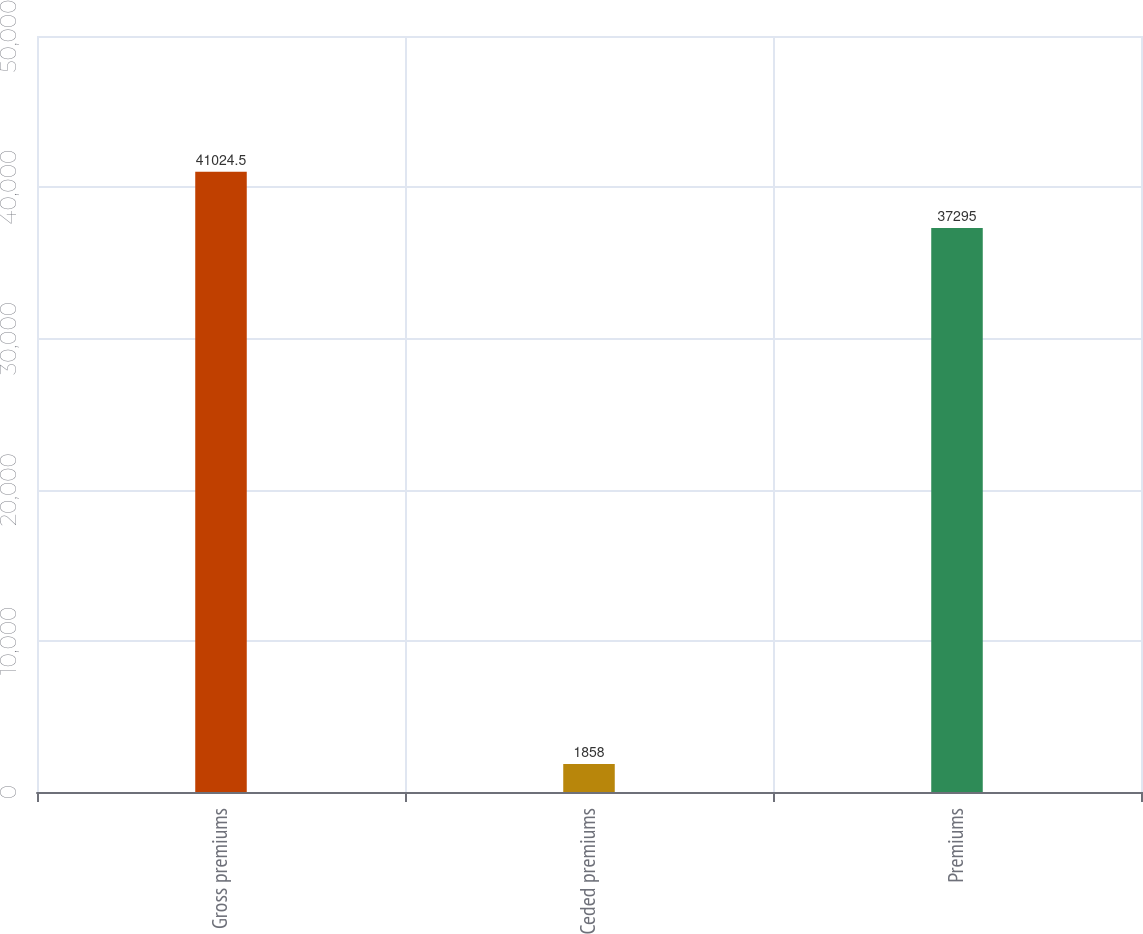Convert chart. <chart><loc_0><loc_0><loc_500><loc_500><bar_chart><fcel>Gross premiums<fcel>Ceded premiums<fcel>Premiums<nl><fcel>41024.5<fcel>1858<fcel>37295<nl></chart> 